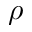Convert formula to latex. <formula><loc_0><loc_0><loc_500><loc_500>\rho</formula> 